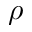Convert formula to latex. <formula><loc_0><loc_0><loc_500><loc_500>\rho</formula> 